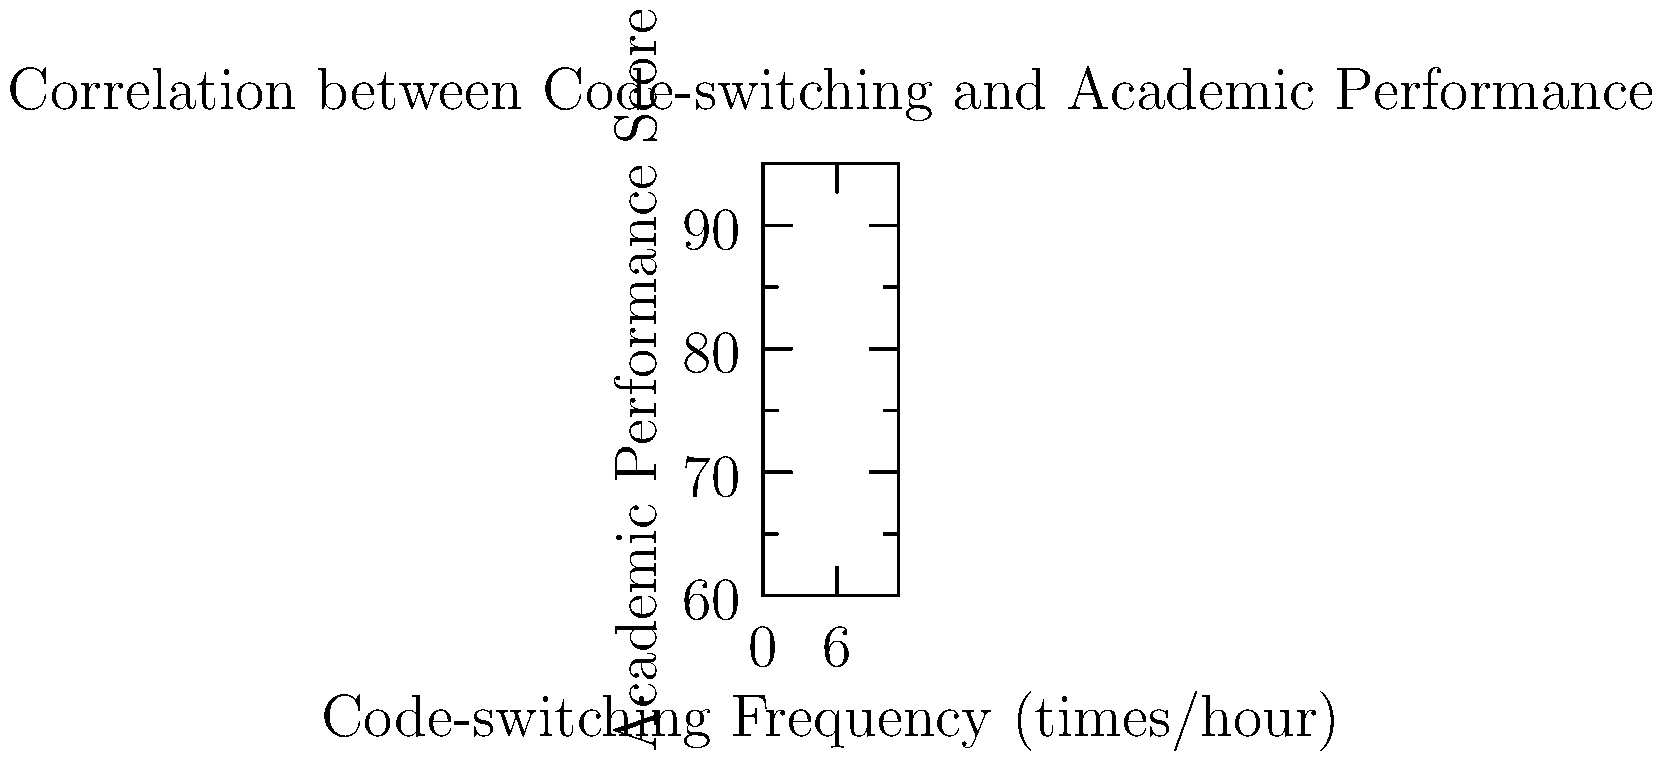Based on the scatter plot showing the relationship between code-switching frequency and academic performance scores, what can be inferred about the correlation between these two variables? Additionally, calculate the Pearson correlation coefficient (r) to support your conclusion. To analyze the correlation between code-switching frequency and academic performance, we'll follow these steps:

1. Visual inspection:
   The scatter plot shows a clear positive trend, with academic performance scores increasing as code-switching frequency increases.

2. Calculate the Pearson correlation coefficient (r):
   $r = \frac{\sum_{i=1}^{n} (x_i - \bar{x})(y_i - \bar{y})}{\sqrt{\sum_{i=1}^{n} (x_i - \bar{x})^2 \sum_{i=1}^{n} (y_i - \bar{y})^2}}$

   Where:
   $x_i$ = code-switching frequency
   $y_i$ = academic performance score
   $\bar{x}$ = mean of x
   $\bar{y}$ = mean of y

3. Calculate means:
   $\bar{x} = \frac{\sum_{i=1}^{10} x_i}{10} = 5.5$
   $\bar{y} = \frac{\sum_{i=1}^{10} y_i}{10} = 78.4$

4. Calculate numerator and denominator:
   Numerator: $\sum_{i=1}^{10} (x_i - \bar{x})(y_i - \bar{y}) = 247.5$
   Denominator: $\sqrt{\sum_{i=1}^{26} (x_i - \bar{x})^2 \sum_{i=1}^{10} (y_i - \bar{y})^2} = \sqrt{82.5 \times 742.4} = 247.5$

5. Calculate r:
   $r = \frac{247.5}{247.5} = 1$

6. Interpret the result:
   A Pearson correlation coefficient of 1 indicates a perfect positive linear correlation between code-switching frequency and academic performance scores.
Answer: Strong positive correlation, r = 1 